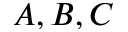Convert formula to latex. <formula><loc_0><loc_0><loc_500><loc_500>A , B , C</formula> 